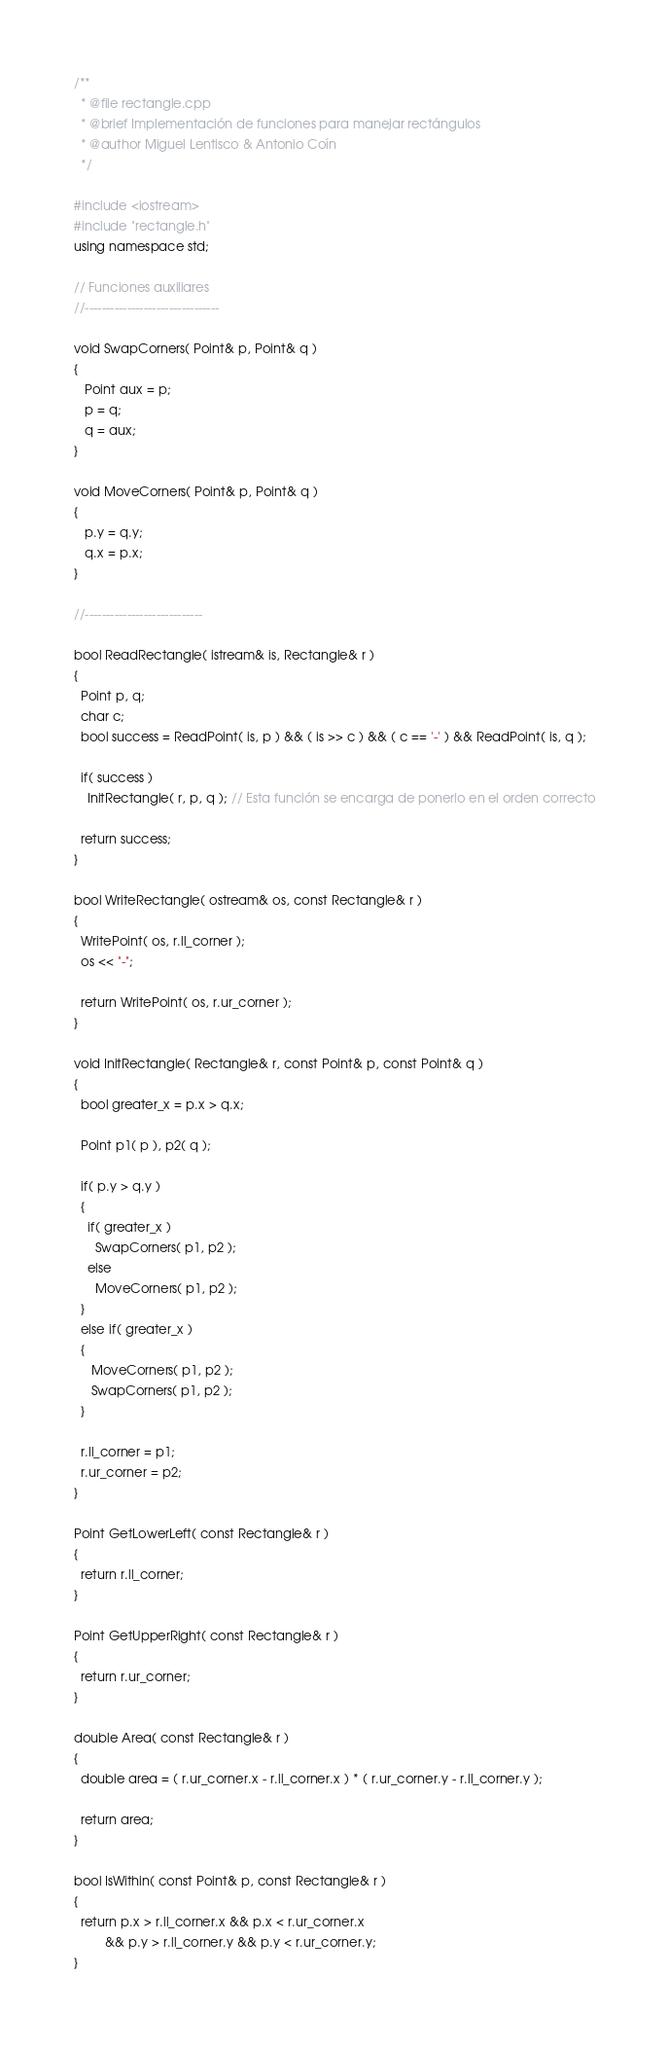<code> <loc_0><loc_0><loc_500><loc_500><_C++_>/**
  * @file rectangle.cpp
  * @brief Implementación de funciones para manejar rectángulos
  * @author Miguel Lentisco & Antonio Coín
  */

#include <iostream>
#include "rectangle.h"
using namespace std;

// Funciones auxiliares
//--------------------------------

void SwapCorners( Point& p, Point& q )
{
   Point aux = p;
   p = q;
   q = aux;
}

void MoveCorners( Point& p, Point& q )
{
   p.y = q.y;
   q.x = p.x;
}

//----------------------------

bool ReadRectangle( istream& is, Rectangle& r )
{
  Point p, q;
  char c;
  bool success = ReadPoint( is, p ) && ( is >> c ) && ( c == '-' ) && ReadPoint( is, q );

  if( success )
    InitRectangle( r, p, q ); // Esta función se encarga de ponerlo en el orden correcto

  return success;
}

bool WriteRectangle( ostream& os, const Rectangle& r )
{
  WritePoint( os, r.ll_corner );
  os << "-";

  return WritePoint( os, r.ur_corner );
}

void InitRectangle( Rectangle& r, const Point& p, const Point& q )
{
  bool greater_x = p.x > q.x;

  Point p1( p ), p2( q );

  if( p.y > q.y )
  {
    if( greater_x )
      SwapCorners( p1, p2 );
    else
      MoveCorners( p1, p2 );
  }
  else if( greater_x )
  {
     MoveCorners( p1, p2 );
     SwapCorners( p1, p2 );
  }

  r.ll_corner = p1;
  r.ur_corner = p2;
}

Point GetLowerLeft( const Rectangle& r )
{
  return r.ll_corner;
}

Point GetUpperRight( const Rectangle& r )
{
  return r.ur_corner;
}

double Area( const Rectangle& r )
{
  double area = ( r.ur_corner.x - r.ll_corner.x ) * ( r.ur_corner.y - r.ll_corner.y );

  return area;
}

bool IsWithin( const Point& p, const Rectangle& r )
{
  return p.x > r.ll_corner.x && p.x < r.ur_corner.x
         && p.y > r.ll_corner.y && p.y < r.ur_corner.y;
}
</code> 